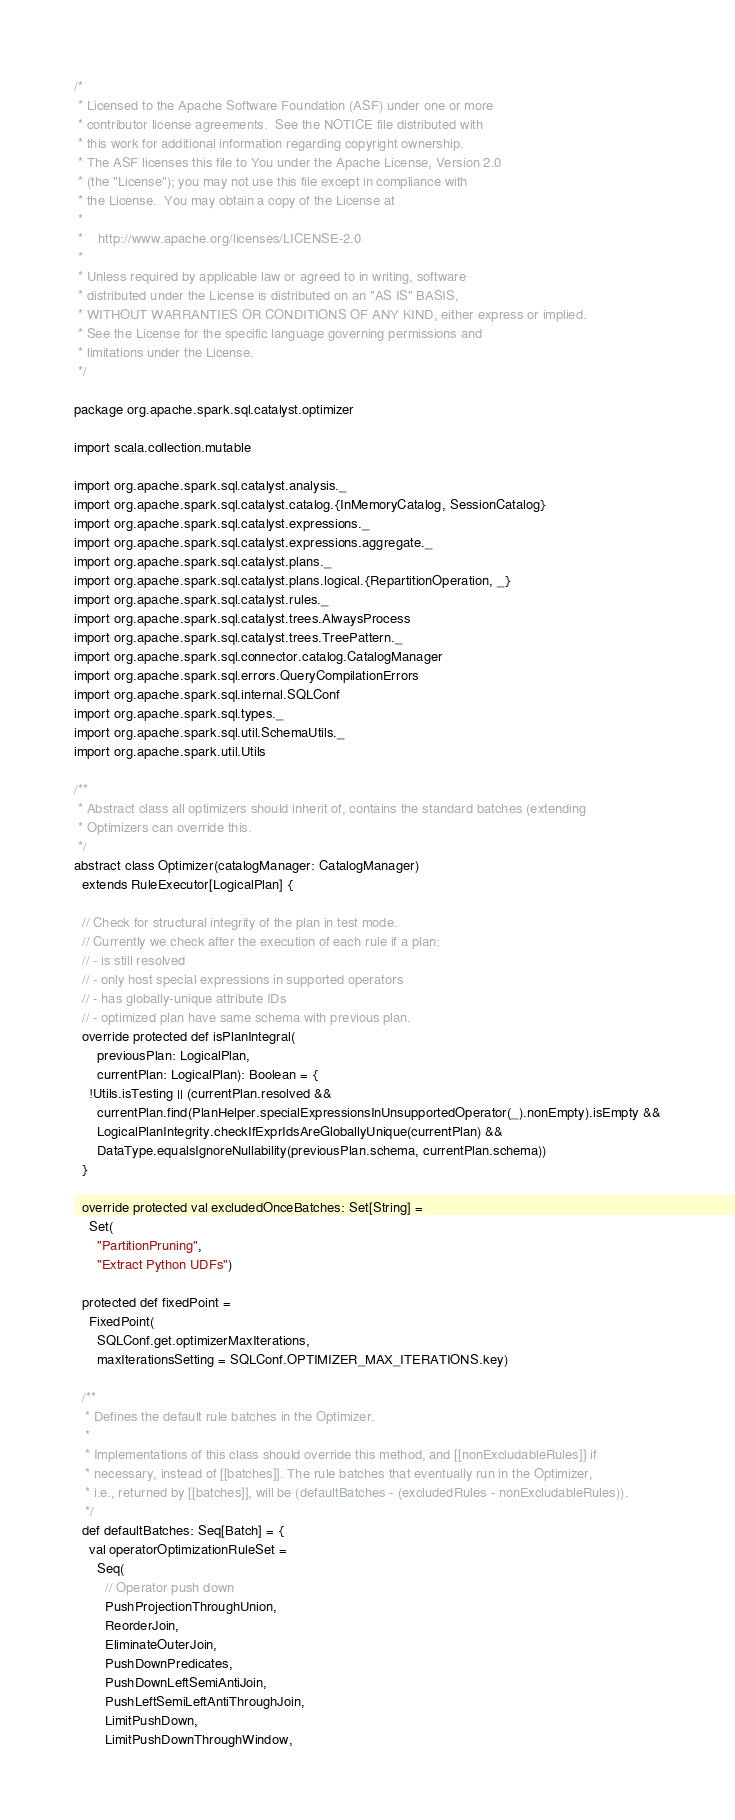<code> <loc_0><loc_0><loc_500><loc_500><_Scala_>/*
 * Licensed to the Apache Software Foundation (ASF) under one or more
 * contributor license agreements.  See the NOTICE file distributed with
 * this work for additional information regarding copyright ownership.
 * The ASF licenses this file to You under the Apache License, Version 2.0
 * (the "License"); you may not use this file except in compliance with
 * the License.  You may obtain a copy of the License at
 *
 *    http://www.apache.org/licenses/LICENSE-2.0
 *
 * Unless required by applicable law or agreed to in writing, software
 * distributed under the License is distributed on an "AS IS" BASIS,
 * WITHOUT WARRANTIES OR CONDITIONS OF ANY KIND, either express or implied.
 * See the License for the specific language governing permissions and
 * limitations under the License.
 */

package org.apache.spark.sql.catalyst.optimizer

import scala.collection.mutable

import org.apache.spark.sql.catalyst.analysis._
import org.apache.spark.sql.catalyst.catalog.{InMemoryCatalog, SessionCatalog}
import org.apache.spark.sql.catalyst.expressions._
import org.apache.spark.sql.catalyst.expressions.aggregate._
import org.apache.spark.sql.catalyst.plans._
import org.apache.spark.sql.catalyst.plans.logical.{RepartitionOperation, _}
import org.apache.spark.sql.catalyst.rules._
import org.apache.spark.sql.catalyst.trees.AlwaysProcess
import org.apache.spark.sql.catalyst.trees.TreePattern._
import org.apache.spark.sql.connector.catalog.CatalogManager
import org.apache.spark.sql.errors.QueryCompilationErrors
import org.apache.spark.sql.internal.SQLConf
import org.apache.spark.sql.types._
import org.apache.spark.sql.util.SchemaUtils._
import org.apache.spark.util.Utils

/**
 * Abstract class all optimizers should inherit of, contains the standard batches (extending
 * Optimizers can override this.
 */
abstract class Optimizer(catalogManager: CatalogManager)
  extends RuleExecutor[LogicalPlan] {

  // Check for structural integrity of the plan in test mode.
  // Currently we check after the execution of each rule if a plan:
  // - is still resolved
  // - only host special expressions in supported operators
  // - has globally-unique attribute IDs
  // - optimized plan have same schema with previous plan.
  override protected def isPlanIntegral(
      previousPlan: LogicalPlan,
      currentPlan: LogicalPlan): Boolean = {
    !Utils.isTesting || (currentPlan.resolved &&
      currentPlan.find(PlanHelper.specialExpressionsInUnsupportedOperator(_).nonEmpty).isEmpty &&
      LogicalPlanIntegrity.checkIfExprIdsAreGloballyUnique(currentPlan) &&
      DataType.equalsIgnoreNullability(previousPlan.schema, currentPlan.schema))
  }

  override protected val excludedOnceBatches: Set[String] =
    Set(
      "PartitionPruning",
      "Extract Python UDFs")

  protected def fixedPoint =
    FixedPoint(
      SQLConf.get.optimizerMaxIterations,
      maxIterationsSetting = SQLConf.OPTIMIZER_MAX_ITERATIONS.key)

  /**
   * Defines the default rule batches in the Optimizer.
   *
   * Implementations of this class should override this method, and [[nonExcludableRules]] if
   * necessary, instead of [[batches]]. The rule batches that eventually run in the Optimizer,
   * i.e., returned by [[batches]], will be (defaultBatches - (excludedRules - nonExcludableRules)).
   */
  def defaultBatches: Seq[Batch] = {
    val operatorOptimizationRuleSet =
      Seq(
        // Operator push down
        PushProjectionThroughUnion,
        ReorderJoin,
        EliminateOuterJoin,
        PushDownPredicates,
        PushDownLeftSemiAntiJoin,
        PushLeftSemiLeftAntiThroughJoin,
        LimitPushDown,
        LimitPushDownThroughWindow,</code> 